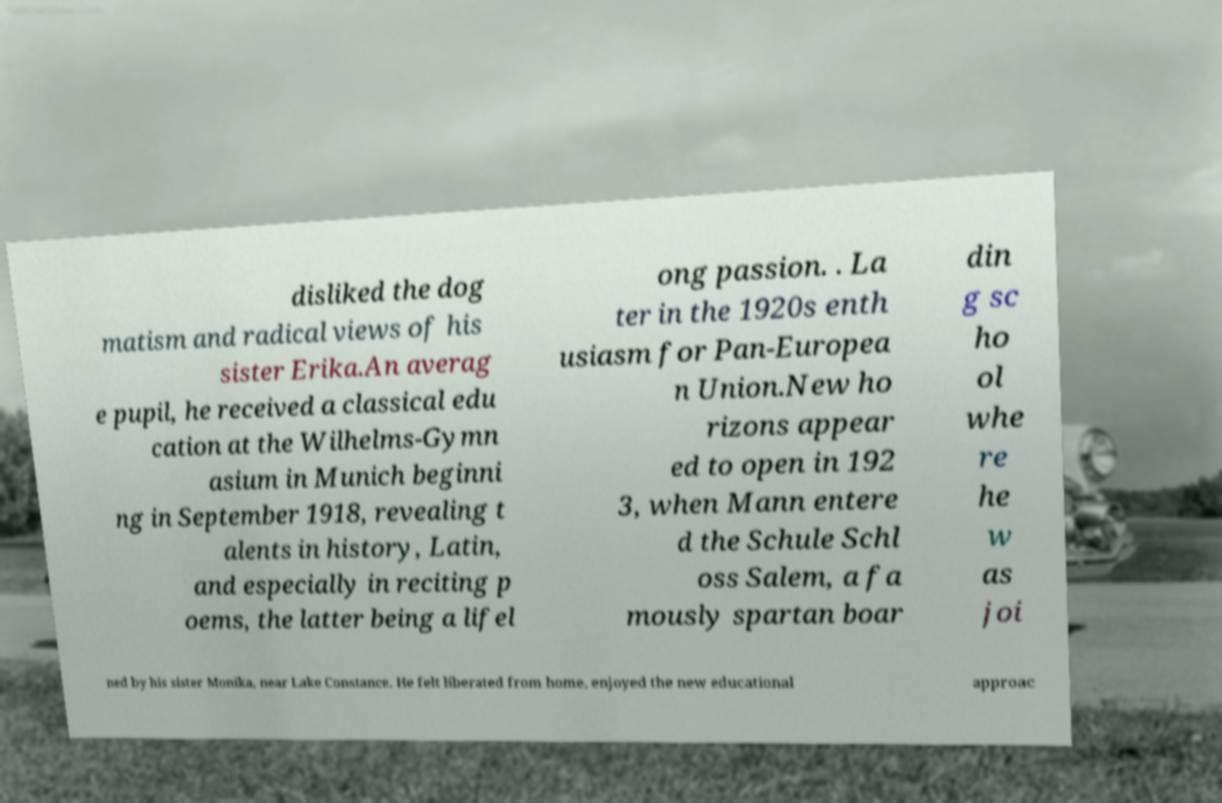What messages or text are displayed in this image? I need them in a readable, typed format. disliked the dog matism and radical views of his sister Erika.An averag e pupil, he received a classical edu cation at the Wilhelms-Gymn asium in Munich beginni ng in September 1918, revealing t alents in history, Latin, and especially in reciting p oems, the latter being a lifel ong passion. . La ter in the 1920s enth usiasm for Pan-Europea n Union.New ho rizons appear ed to open in 192 3, when Mann entere d the Schule Schl oss Salem, a fa mously spartan boar din g sc ho ol whe re he w as joi ned by his sister Monika, near Lake Constance. He felt liberated from home, enjoyed the new educational approac 